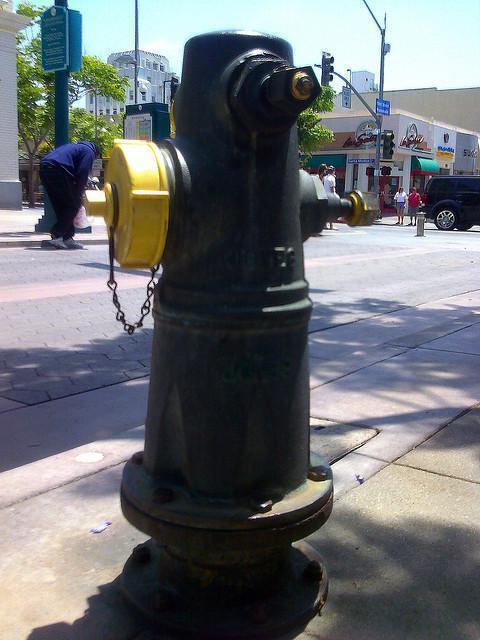What is inside the green and yellow object on the sidewalk?
Indicate the correct choice and explain in the format: 'Answer: answer
Rationale: rationale.'
Options: Mud, water, beer, candy. Answer: water.
Rationale: It is a fire hydrant. 